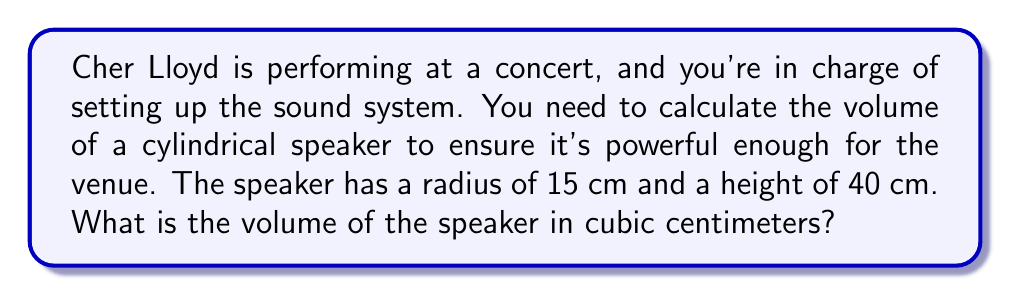Teach me how to tackle this problem. To find the volume of a cylindrical speaker, we need to use the formula for the volume of a cylinder:

$$V = \pi r^2 h$$

Where:
$V$ = volume
$\pi$ = pi (approximately 3.14159)
$r$ = radius of the base
$h$ = height of the cylinder

Given:
$r = 15$ cm
$h = 40$ cm

Let's substitute these values into the formula:

$$V = \pi (15 \text{ cm})^2 (40 \text{ cm})$$

Now, let's calculate step by step:

1) First, calculate $r^2$:
   $15^2 = 225$

2) Multiply by $\pi$:
   $\pi \cdot 225 \approx 706.86$

3) Multiply by the height:
   $706.86 \cdot 40 = 28,274.33$

Therefore, the volume of the cylindrical speaker is approximately 28,274.33 cubic centimeters.

[asy]
import geometry;

size(200);
real r = 1.5;
real h = 4;

path base = circle((0,0), r);
path top = circle((0,h), r);

draw(base);
draw(top);
draw((r,0)--(r,h));
draw((-r,0)--(-r,h));

label("r", (r/2,0), E);
label("h", (r,h/2), E);

[/asy]
Answer: $28,274.33 \text{ cm}^3$ 